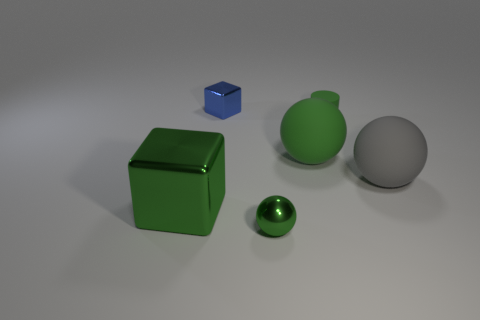Is there anything else that is the same shape as the tiny matte object?
Keep it short and to the point. No. Is the size of the shiny object behind the big gray matte ball the same as the ball right of the green matte cylinder?
Offer a terse response. No. What is the color of the large thing left of the metallic cube that is to the right of the green metallic cube?
Give a very brief answer. Green. There is a ball that is the same size as the gray thing; what is it made of?
Ensure brevity in your answer.  Rubber. What number of matte things are either big green balls or large balls?
Make the answer very short. 2. The ball that is both to the left of the matte cylinder and in front of the large green matte ball is what color?
Ensure brevity in your answer.  Green. There is a large green ball; how many large green metallic cubes are behind it?
Give a very brief answer. 0. What is the material of the big green block?
Ensure brevity in your answer.  Metal. What color is the small thing right of the big green thing that is behind the big green thing that is in front of the gray object?
Keep it short and to the point. Green. What number of green cylinders have the same size as the gray rubber sphere?
Provide a succinct answer. 0. 